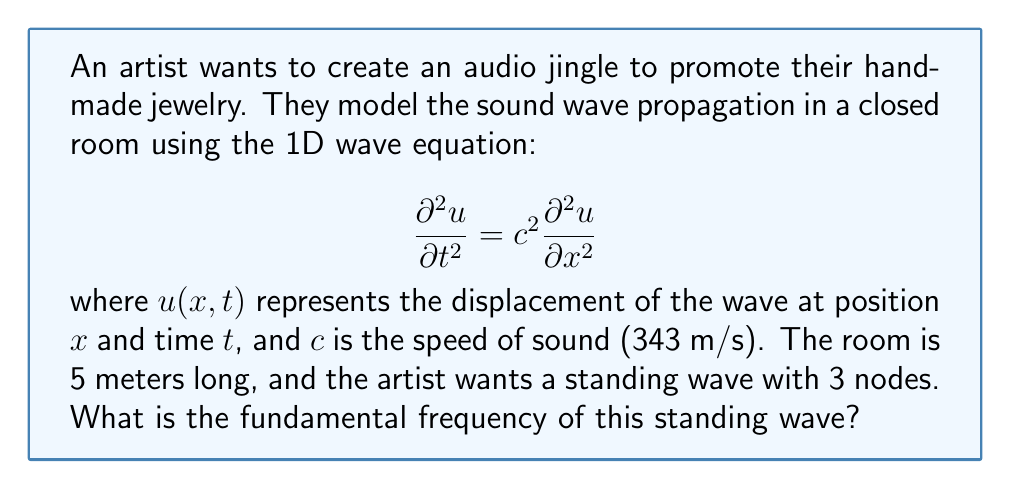Give your solution to this math problem. To solve this problem, we'll follow these steps:

1) For a standing wave in a closed room, we have fixed boundary conditions:
   $u(0,t) = u(L,t) = 0$, where $L$ is the length of the room.

2) The general solution for a standing wave is:
   $$u(x,t) = (A \sin(kx) + B \cos(kx))(C \sin(\omega t) + D \cos(\omega t))$$

3) Applying the boundary conditions:
   At $x=0$: $u(0,t) = 0$ implies $B = 0$
   At $x=L$: $u(L,t) = 0$ implies $\sin(kL) = 0$

4) For $\sin(kL) = 0$, we must have $kL = n\pi$, where $n$ is an integer.

5) The wave number $k$ is related to the wavelength $\lambda$ by $k = \frac{2\pi}{\lambda}$

6) Substituting this into $kL = n\pi$:
   $$\frac{2\pi}{\lambda}L = n\pi$$
   $$\lambda = \frac{2L}{n}$$

7) For 3 nodes in a standing wave, we need $n = 3$. So:
   $$\lambda = \frac{2L}{3} = \frac{2(5)}{3} = \frac{10}{3} \text{ meters}$$

8) The frequency $f$ is related to wavelength $\lambda$ and speed $c$ by:
   $$f = \frac{c}{\lambda}$$

9) Substituting our values:
   $$f = \frac{343}{\frac{10}{3}} = 102.9 \text{ Hz}$$

Therefore, the fundamental frequency of the standing wave is approximately 102.9 Hz.
Answer: 102.9 Hz 